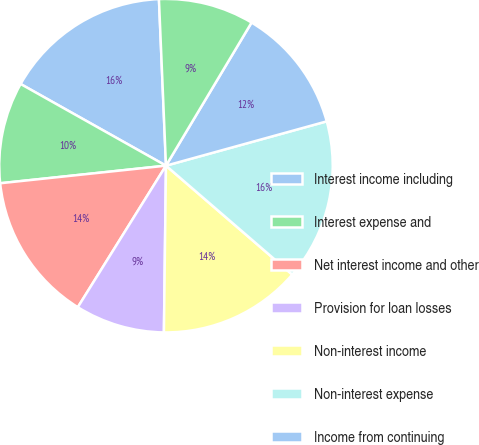Convert chart. <chart><loc_0><loc_0><loc_500><loc_500><pie_chart><fcel>Interest income including<fcel>Interest expense and<fcel>Net interest income and other<fcel>Provision for loan losses<fcel>Non-interest income<fcel>Non-interest expense<fcel>Income from continuing<fcel>Income tax expense<nl><fcel>16.18%<fcel>9.83%<fcel>14.45%<fcel>8.67%<fcel>13.87%<fcel>15.61%<fcel>12.14%<fcel>9.25%<nl></chart> 